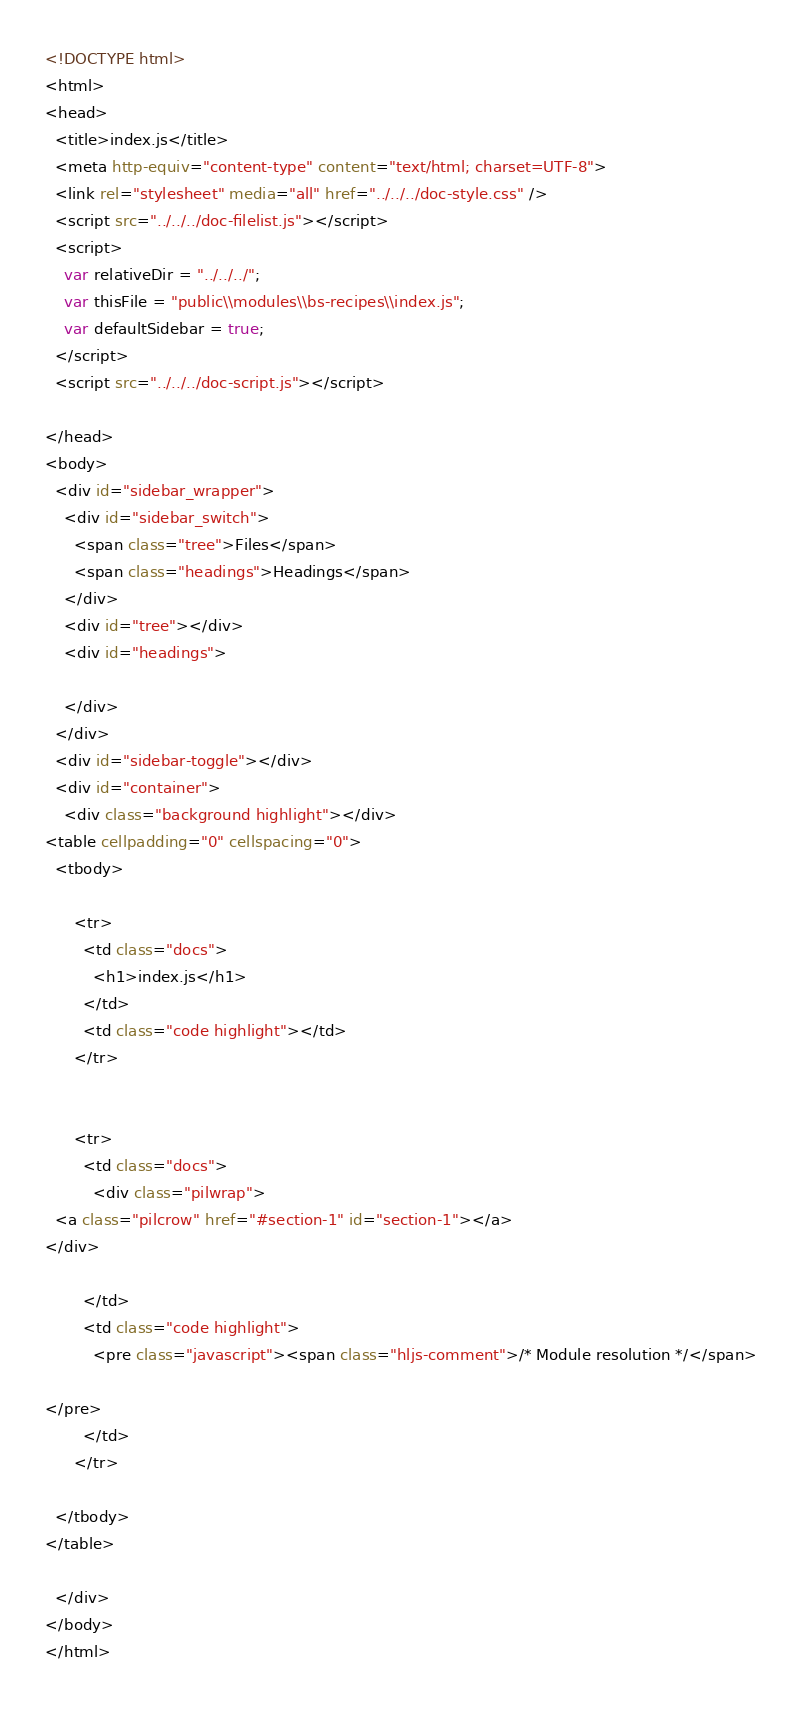<code> <loc_0><loc_0><loc_500><loc_500><_HTML_><!DOCTYPE html>
<html>
<head>
  <title>index.js</title>
  <meta http-equiv="content-type" content="text/html; charset=UTF-8">
  <link rel="stylesheet" media="all" href="../../../doc-style.css" />
  <script src="../../../doc-filelist.js"></script>
  <script>
    var relativeDir = "../../../";
    var thisFile = "public\\modules\\bs-recipes\\index.js";
    var defaultSidebar = true;
  </script>
  <script src="../../../doc-script.js"></script>

</head>
<body>
  <div id="sidebar_wrapper">
    <div id="sidebar_switch">
      <span class="tree">Files</span>
      <span class="headings">Headings</span>
    </div>
    <div id="tree"></div>
    <div id="headings">

    </div>
  </div>
  <div id="sidebar-toggle"></div>
  <div id="container">
    <div class="background highlight"></div>
<table cellpadding="0" cellspacing="0">
  <tbody>
    
      <tr>
        <td class="docs">
          <h1>index.js</h1>
        </td>
        <td class="code highlight"></td>
      </tr>
    
    
      <tr>
        <td class="docs">
          <div class="pilwrap">
  <a class="pilcrow" href="#section-1" id="section-1"></a>
</div>

        </td>
        <td class="code highlight">
          <pre class="javascript"><span class="hljs-comment">/* Module resolution */</span>

</pre>
        </td>
      </tr>
    
  </tbody>
</table>

  </div>
</body>
</html>
</code> 